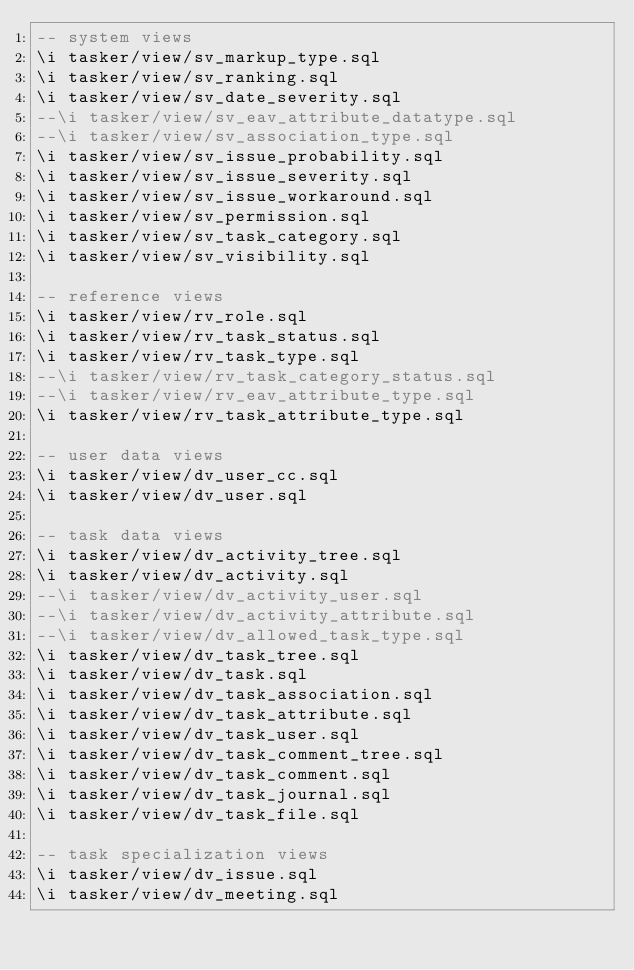Convert code to text. <code><loc_0><loc_0><loc_500><loc_500><_SQL_>-- system views
\i tasker/view/sv_markup_type.sql
\i tasker/view/sv_ranking.sql
\i tasker/view/sv_date_severity.sql
--\i tasker/view/sv_eav_attribute_datatype.sql
--\i tasker/view/sv_association_type.sql
\i tasker/view/sv_issue_probability.sql
\i tasker/view/sv_issue_severity.sql
\i tasker/view/sv_issue_workaround.sql
\i tasker/view/sv_permission.sql
\i tasker/view/sv_task_category.sql
\i tasker/view/sv_visibility.sql

-- reference views
\i tasker/view/rv_role.sql
\i tasker/view/rv_task_status.sql
\i tasker/view/rv_task_type.sql
--\i tasker/view/rv_task_category_status.sql
--\i tasker/view/rv_eav_attribute_type.sql
\i tasker/view/rv_task_attribute_type.sql

-- user data views
\i tasker/view/dv_user_cc.sql
\i tasker/view/dv_user.sql

-- task data views
\i tasker/view/dv_activity_tree.sql
\i tasker/view/dv_activity.sql
--\i tasker/view/dv_activity_user.sql
--\i tasker/view/dv_activity_attribute.sql
--\i tasker/view/dv_allowed_task_type.sql
\i tasker/view/dv_task_tree.sql
\i tasker/view/dv_task.sql
\i tasker/view/dv_task_association.sql
\i tasker/view/dv_task_attribute.sql
\i tasker/view/dv_task_user.sql
\i tasker/view/dv_task_comment_tree.sql
\i tasker/view/dv_task_comment.sql
\i tasker/view/dv_task_journal.sql
\i tasker/view/dv_task_file.sql

-- task specialization views
\i tasker/view/dv_issue.sql
\i tasker/view/dv_meeting.sql
</code> 